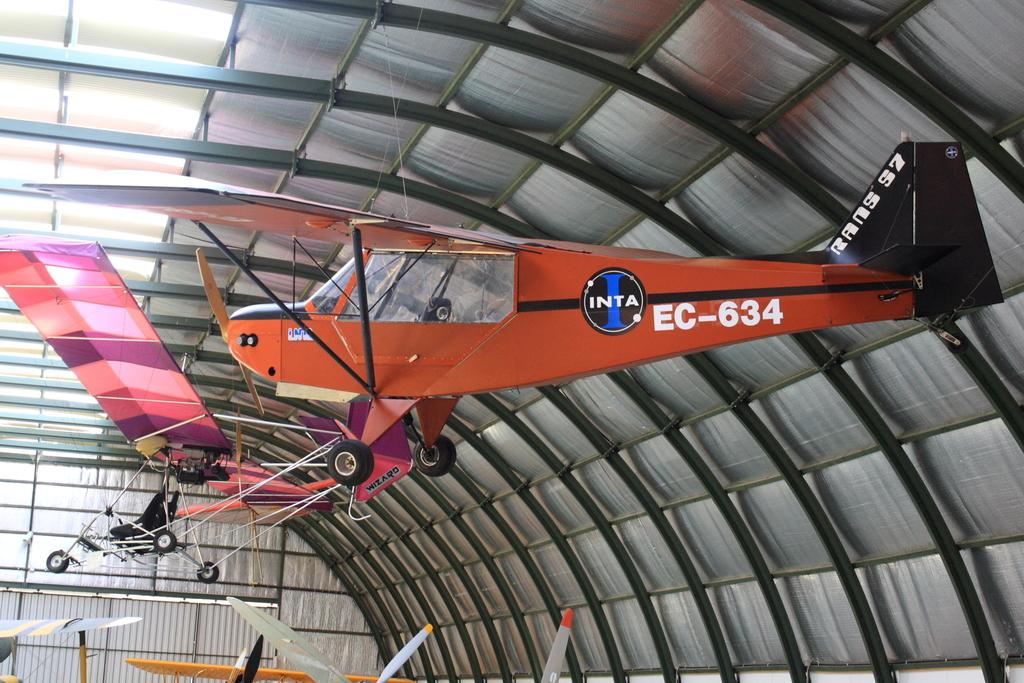<image>
Describe the image concisely. A red airplane is hanging from the roof of a hangar with the text EC-634. 